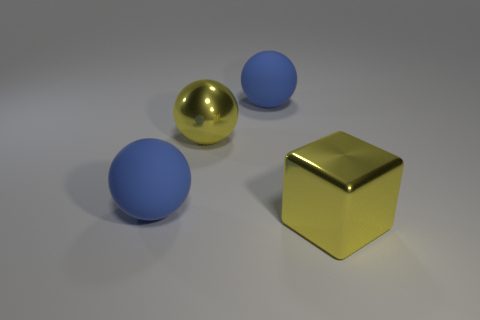Add 1 big yellow objects. How many objects exist? 5 Subtract all cubes. How many objects are left? 3 Subtract all big metal cubes. Subtract all large yellow metal blocks. How many objects are left? 2 Add 4 matte balls. How many matte balls are left? 6 Add 1 balls. How many balls exist? 4 Subtract 0 cyan balls. How many objects are left? 4 